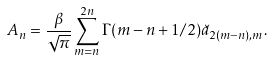Convert formula to latex. <formula><loc_0><loc_0><loc_500><loc_500>A _ { n } = \frac { \beta } { \sqrt { \pi } } \sum _ { m = n } ^ { 2 n } \Gamma ( m - n + 1 / 2 ) \breve { a } _ { 2 ( m - n ) , m } .</formula> 